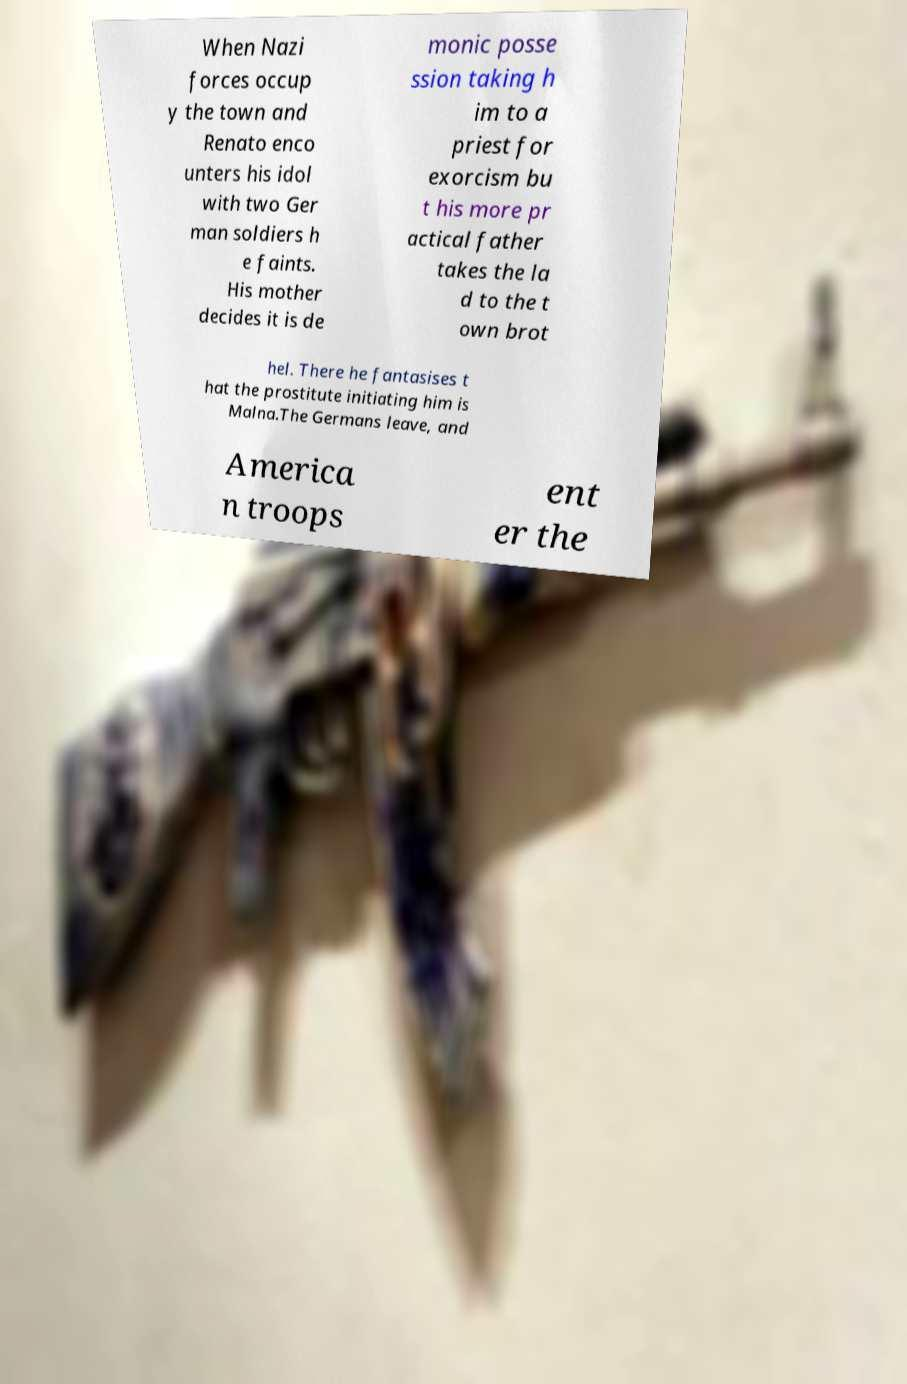For documentation purposes, I need the text within this image transcribed. Could you provide that? When Nazi forces occup y the town and Renato enco unters his idol with two Ger man soldiers h e faints. His mother decides it is de monic posse ssion taking h im to a priest for exorcism bu t his more pr actical father takes the la d to the t own brot hel. There he fantasises t hat the prostitute initiating him is Malna.The Germans leave, and America n troops ent er the 